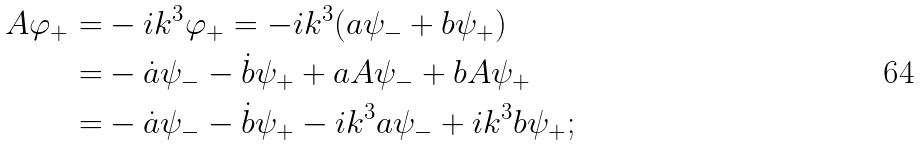Convert formula to latex. <formula><loc_0><loc_0><loc_500><loc_500>A \varphi _ { + } = & - i k ^ { 3 } \varphi _ { + } = - i k ^ { 3 } ( a \psi _ { - } + b \psi _ { + } ) \\ = & - \dot { a } \psi _ { - } - \dot { b } \psi _ { + } + a A \psi _ { - } + b A \psi _ { + } \\ = & - \dot { a } \psi _ { - } - \dot { b } \psi _ { + } - i k ^ { 3 } a \psi _ { - } + i k ^ { 3 } b \psi _ { + } ;</formula> 